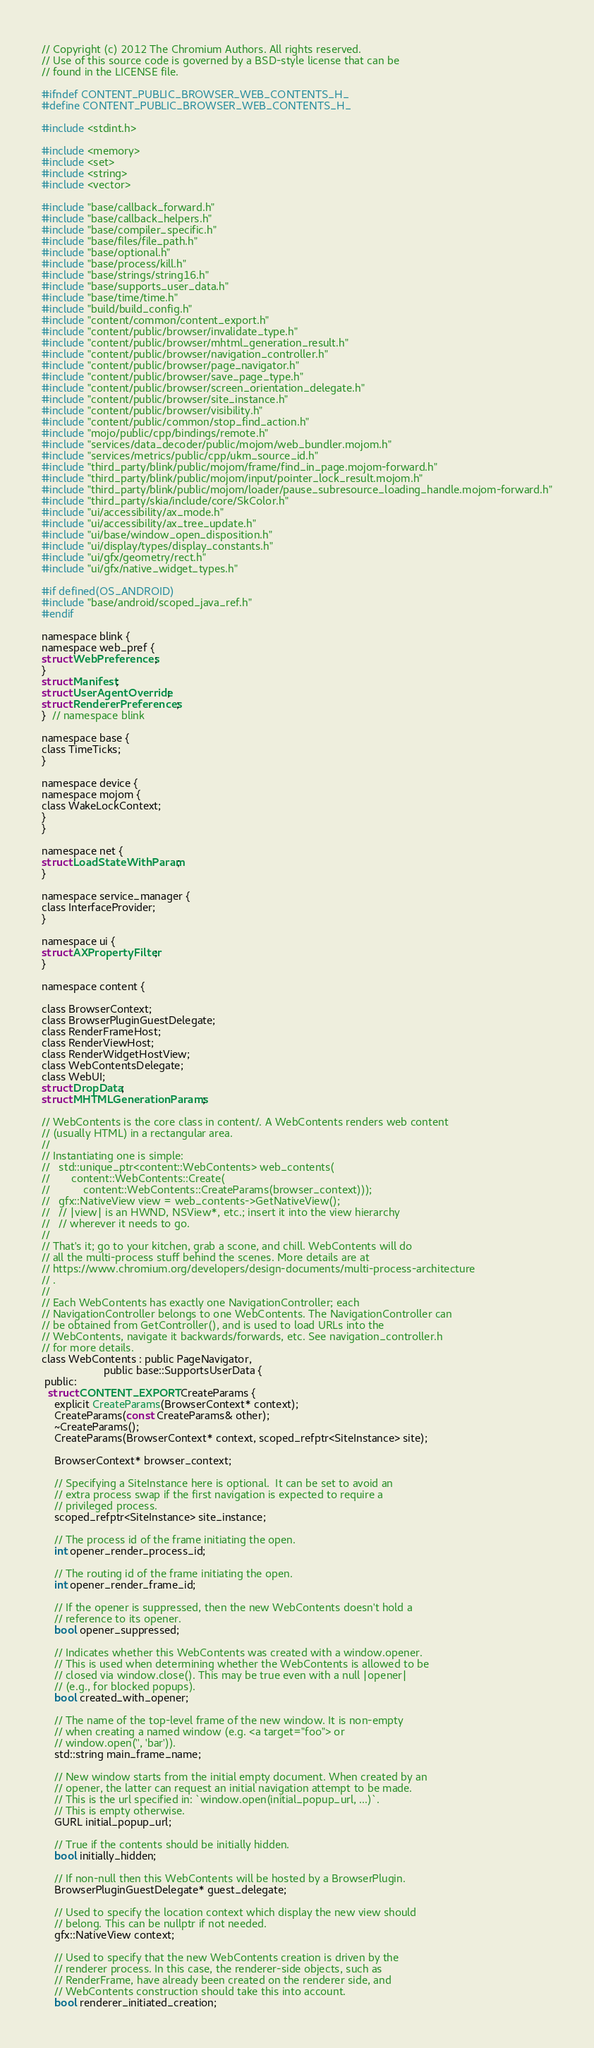Convert code to text. <code><loc_0><loc_0><loc_500><loc_500><_C_>// Copyright (c) 2012 The Chromium Authors. All rights reserved.
// Use of this source code is governed by a BSD-style license that can be
// found in the LICENSE file.

#ifndef CONTENT_PUBLIC_BROWSER_WEB_CONTENTS_H_
#define CONTENT_PUBLIC_BROWSER_WEB_CONTENTS_H_

#include <stdint.h>

#include <memory>
#include <set>
#include <string>
#include <vector>

#include "base/callback_forward.h"
#include "base/callback_helpers.h"
#include "base/compiler_specific.h"
#include "base/files/file_path.h"
#include "base/optional.h"
#include "base/process/kill.h"
#include "base/strings/string16.h"
#include "base/supports_user_data.h"
#include "base/time/time.h"
#include "build/build_config.h"
#include "content/common/content_export.h"
#include "content/public/browser/invalidate_type.h"
#include "content/public/browser/mhtml_generation_result.h"
#include "content/public/browser/navigation_controller.h"
#include "content/public/browser/page_navigator.h"
#include "content/public/browser/save_page_type.h"
#include "content/public/browser/screen_orientation_delegate.h"
#include "content/public/browser/site_instance.h"
#include "content/public/browser/visibility.h"
#include "content/public/common/stop_find_action.h"
#include "mojo/public/cpp/bindings/remote.h"
#include "services/data_decoder/public/mojom/web_bundler.mojom.h"
#include "services/metrics/public/cpp/ukm_source_id.h"
#include "third_party/blink/public/mojom/frame/find_in_page.mojom-forward.h"
#include "third_party/blink/public/mojom/input/pointer_lock_result.mojom.h"
#include "third_party/blink/public/mojom/loader/pause_subresource_loading_handle.mojom-forward.h"
#include "third_party/skia/include/core/SkColor.h"
#include "ui/accessibility/ax_mode.h"
#include "ui/accessibility/ax_tree_update.h"
#include "ui/base/window_open_disposition.h"
#include "ui/display/types/display_constants.h"
#include "ui/gfx/geometry/rect.h"
#include "ui/gfx/native_widget_types.h"

#if defined(OS_ANDROID)
#include "base/android/scoped_java_ref.h"
#endif

namespace blink {
namespace web_pref {
struct WebPreferences;
}
struct Manifest;
struct UserAgentOverride;
struct RendererPreferences;
}  // namespace blink

namespace base {
class TimeTicks;
}

namespace device {
namespace mojom {
class WakeLockContext;
}
}

namespace net {
struct LoadStateWithParam;
}

namespace service_manager {
class InterfaceProvider;
}

namespace ui {
struct AXPropertyFilter;
}

namespace content {

class BrowserContext;
class BrowserPluginGuestDelegate;
class RenderFrameHost;
class RenderViewHost;
class RenderWidgetHostView;
class WebContentsDelegate;
class WebUI;
struct DropData;
struct MHTMLGenerationParams;

// WebContents is the core class in content/. A WebContents renders web content
// (usually HTML) in a rectangular area.
//
// Instantiating one is simple:
//   std::unique_ptr<content::WebContents> web_contents(
//       content::WebContents::Create(
//           content::WebContents::CreateParams(browser_context)));
//   gfx::NativeView view = web_contents->GetNativeView();
//   // |view| is an HWND, NSView*, etc.; insert it into the view hierarchy
//   // wherever it needs to go.
//
// That's it; go to your kitchen, grab a scone, and chill. WebContents will do
// all the multi-process stuff behind the scenes. More details are at
// https://www.chromium.org/developers/design-documents/multi-process-architecture
// .
//
// Each WebContents has exactly one NavigationController; each
// NavigationController belongs to one WebContents. The NavigationController can
// be obtained from GetController(), and is used to load URLs into the
// WebContents, navigate it backwards/forwards, etc. See navigation_controller.h
// for more details.
class WebContents : public PageNavigator,
                    public base::SupportsUserData {
 public:
  struct CONTENT_EXPORT CreateParams {
    explicit CreateParams(BrowserContext* context);
    CreateParams(const CreateParams& other);
    ~CreateParams();
    CreateParams(BrowserContext* context, scoped_refptr<SiteInstance> site);

    BrowserContext* browser_context;

    // Specifying a SiteInstance here is optional.  It can be set to avoid an
    // extra process swap if the first navigation is expected to require a
    // privileged process.
    scoped_refptr<SiteInstance> site_instance;

    // The process id of the frame initiating the open.
    int opener_render_process_id;

    // The routing id of the frame initiating the open.
    int opener_render_frame_id;

    // If the opener is suppressed, then the new WebContents doesn't hold a
    // reference to its opener.
    bool opener_suppressed;

    // Indicates whether this WebContents was created with a window.opener.
    // This is used when determining whether the WebContents is allowed to be
    // closed via window.close(). This may be true even with a null |opener|
    // (e.g., for blocked popups).
    bool created_with_opener;

    // The name of the top-level frame of the new window. It is non-empty
    // when creating a named window (e.g. <a target="foo"> or
    // window.open('', 'bar')).
    std::string main_frame_name;

    // New window starts from the initial empty document. When created by an
    // opener, the latter can request an initial navigation attempt to be made.
    // This is the url specified in: `window.open(initial_popup_url, ...)`.
    // This is empty otherwise.
    GURL initial_popup_url;

    // True if the contents should be initially hidden.
    bool initially_hidden;

    // If non-null then this WebContents will be hosted by a BrowserPlugin.
    BrowserPluginGuestDelegate* guest_delegate;

    // Used to specify the location context which display the new view should
    // belong. This can be nullptr if not needed.
    gfx::NativeView context;

    // Used to specify that the new WebContents creation is driven by the
    // renderer process. In this case, the renderer-side objects, such as
    // RenderFrame, have already been created on the renderer side, and
    // WebContents construction should take this into account.
    bool renderer_initiated_creation;
</code> 